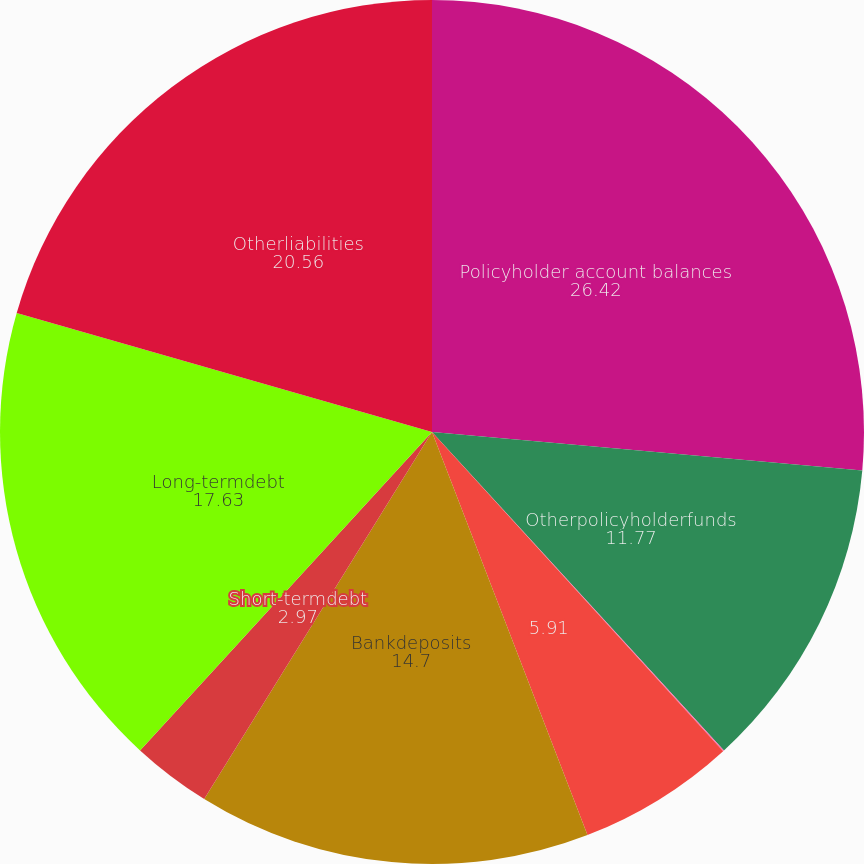<chart> <loc_0><loc_0><loc_500><loc_500><pie_chart><fcel>Policyholder account balances<fcel>Otherpolicyholderfunds<fcel>Policyholderdividendspayable<fcel>Unnamed: 3<fcel>Bankdeposits<fcel>Short-termdebt<fcel>Long-termdebt<fcel>Otherliabilities<nl><fcel>26.42%<fcel>11.77%<fcel>0.04%<fcel>5.91%<fcel>14.7%<fcel>2.97%<fcel>17.63%<fcel>20.56%<nl></chart> 